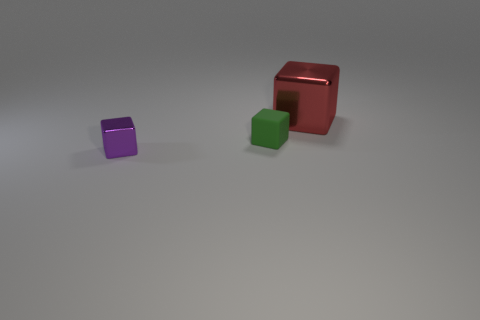Add 3 matte blocks. How many objects exist? 6 Subtract all blue objects. Subtract all small green rubber things. How many objects are left? 2 Add 3 green things. How many green things are left? 4 Add 2 big cubes. How many big cubes exist? 3 Subtract 0 purple spheres. How many objects are left? 3 